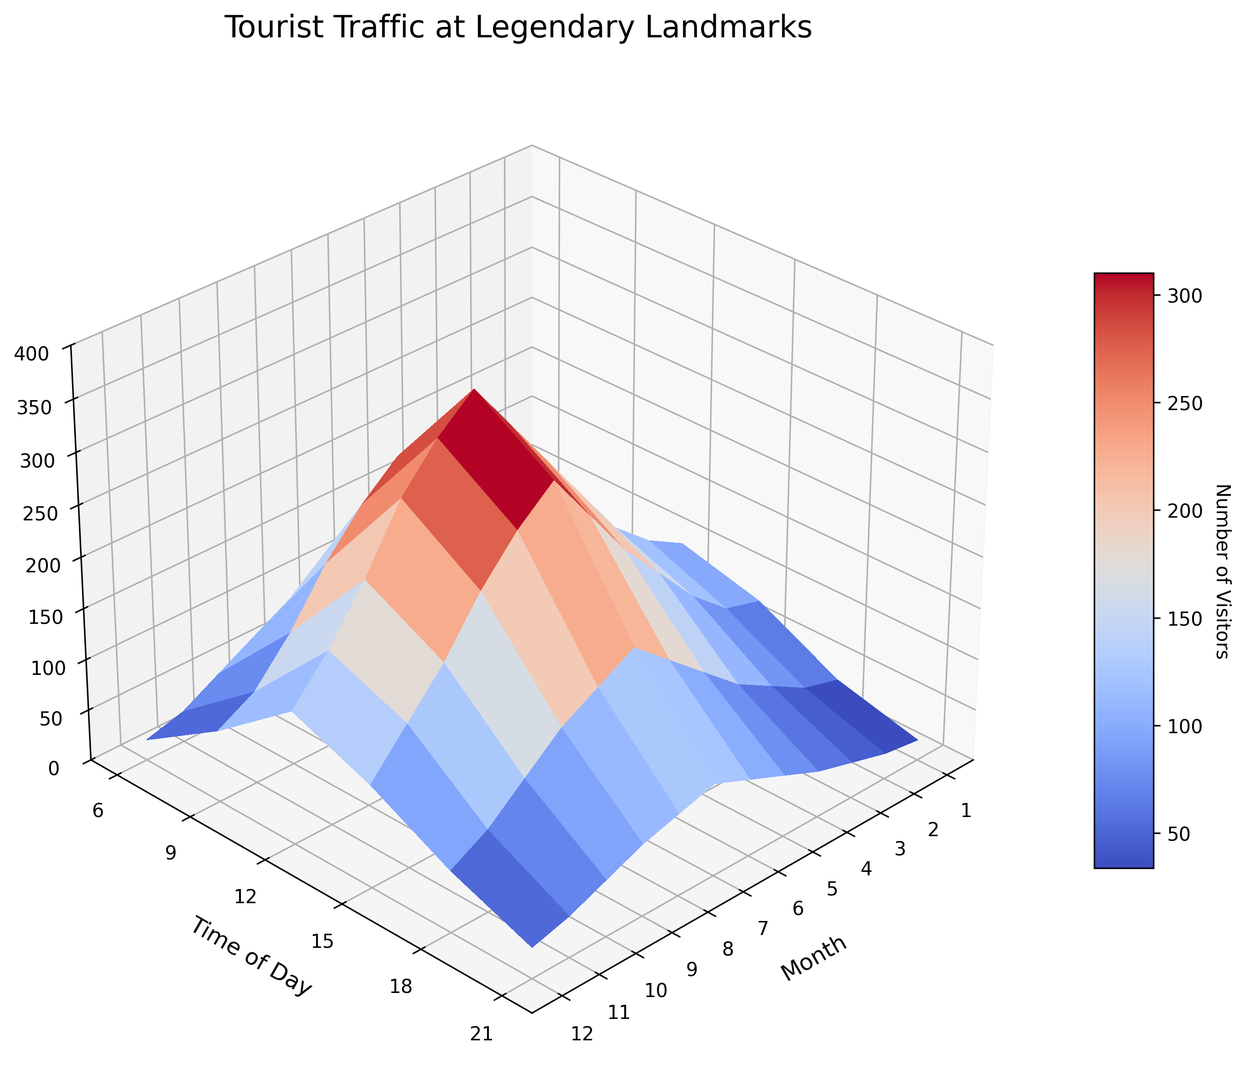Which month and time of day see the highest number of visitors? The highest peak on the 3D surface plot represents the maximum number of visitors. By examining the surface, we notice that July at noon (12 PM) exhibits the highest peak at 350 visitors.
Answer: July at 12 PM During which month is the least number of visitors observed at 6 AM? At 6 AM, the lowest point on the surface indicates the least number of visitors. The January section at 6 AM is visibly the lowest, with 10 visitors.
Answer: January What is the average number of visitors in March at noon across the entire year? Observing March at 12 PM on the plot, we find that the number of visitors is 150. Since we're only looking at one data point in March, the average is the same: 150.
Answer: 150 Which time of day in September sees more visitors, 9 AM or 6 PM? Comparing the surface heights between 9 AM and 6 PM in September, the peak at 9 AM is higher than at 6 PM. September at 9 AM has 180 visitors, and at 6 PM has 140 visitors, thus 9 AM has more visitors.
Answer: 9 AM How does the number of visitors in June at 3 PM compare to the number of visitors in May at the same time? At 3 PM, comparing the surfaces for June and May, June indicates about 250 visitors and May shows about 200. Thus, June at 3 PM has more visitors than May.
Answer: June What's the trend of visitors from morning (6 AM) to evening (9 PM) in December? Analyzing December data from morning to evening, 6 AM has 20, 9 AM has 70, 12 PM has 130, 3 PM has 100, 6 PM has 60, and 9 PM ends with 30 visitors. There's an overall rising trend peaking at noon and then declining.
Answer: Increasing then decreasing Is the number of visitors at noon higher in June or October? Looking at the surface for noon in both June and October, June at noon (12 PM) has 300 visitors while October has 220. Therefore, June has a higher number of visitors at noon.
Answer: June What is the total number of visitors in July at 9 AM and 3 PM? From the plot, July at 9 AM has 250 visitors and at 3 PM has 300 visitors. Summing these gives 250 + 300 = 550 visitors.
Answer: 550 What month shows a significant increase in visitors from 3 PM to 6 PM? Observing the surface, April shows a noticeable spike from 160 visitors at 3 PM to 200 visitors at 6 PM, indicating a significant increase.
Answer: April How does the visitor profile in May at 6 PM compare to November at the same time? Comparing both points, May at 6 PM shows 120 visitors and November at 6 PM has 80 visitors indicating that May has a significantly higher visitor count.
Answer: May 